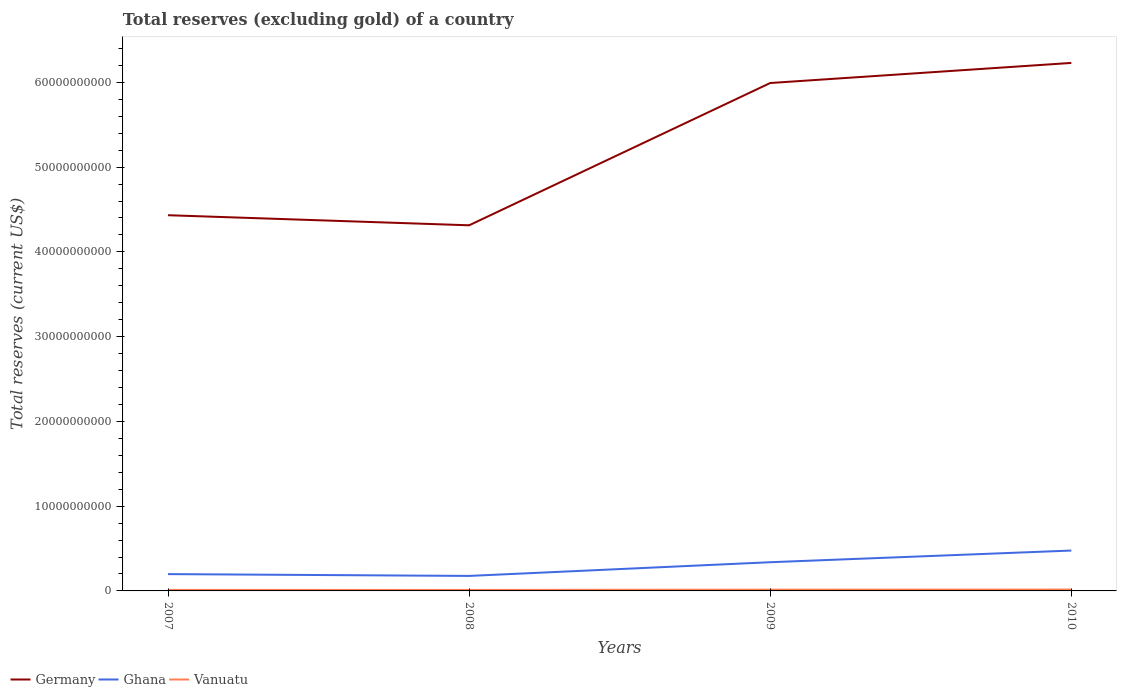Does the line corresponding to Germany intersect with the line corresponding to Ghana?
Your answer should be very brief. No. Across all years, what is the maximum total reserves (excluding gold) in Germany?
Provide a succinct answer. 4.31e+1. What is the total total reserves (excluding gold) in Vanuatu in the graph?
Offer a very short reply. -2.90e+07. What is the difference between the highest and the second highest total reserves (excluding gold) in Vanuatu?
Ensure brevity in your answer.  4.62e+07. Is the total reserves (excluding gold) in Ghana strictly greater than the total reserves (excluding gold) in Germany over the years?
Offer a very short reply. Yes. How many lines are there?
Give a very brief answer. 3. Does the graph contain any zero values?
Your response must be concise. No. How many legend labels are there?
Give a very brief answer. 3. What is the title of the graph?
Your response must be concise. Total reserves (excluding gold) of a country. What is the label or title of the Y-axis?
Your answer should be compact. Total reserves (current US$). What is the Total reserves (current US$) of Germany in 2007?
Keep it short and to the point. 4.43e+1. What is the Total reserves (current US$) in Ghana in 2007?
Offer a very short reply. 1.98e+09. What is the Total reserves (current US$) of Vanuatu in 2007?
Give a very brief answer. 1.20e+08. What is the Total reserves (current US$) in Germany in 2008?
Provide a short and direct response. 4.31e+1. What is the Total reserves (current US$) in Ghana in 2008?
Provide a succinct answer. 1.77e+09. What is the Total reserves (current US$) of Vanuatu in 2008?
Ensure brevity in your answer.  1.15e+08. What is the Total reserves (current US$) in Germany in 2009?
Your answer should be very brief. 5.99e+1. What is the Total reserves (current US$) of Ghana in 2009?
Ensure brevity in your answer.  3.39e+09. What is the Total reserves (current US$) of Vanuatu in 2009?
Your answer should be compact. 1.49e+08. What is the Total reserves (current US$) of Germany in 2010?
Give a very brief answer. 6.23e+1. What is the Total reserves (current US$) in Ghana in 2010?
Make the answer very short. 4.76e+09. What is the Total reserves (current US$) in Vanuatu in 2010?
Provide a succinct answer. 1.61e+08. Across all years, what is the maximum Total reserves (current US$) in Germany?
Provide a short and direct response. 6.23e+1. Across all years, what is the maximum Total reserves (current US$) in Ghana?
Provide a succinct answer. 4.76e+09. Across all years, what is the maximum Total reserves (current US$) of Vanuatu?
Offer a very short reply. 1.61e+08. Across all years, what is the minimum Total reserves (current US$) in Germany?
Provide a short and direct response. 4.31e+1. Across all years, what is the minimum Total reserves (current US$) of Ghana?
Provide a succinct answer. 1.77e+09. Across all years, what is the minimum Total reserves (current US$) in Vanuatu?
Offer a very short reply. 1.15e+08. What is the total Total reserves (current US$) in Germany in the graph?
Provide a succinct answer. 2.10e+11. What is the total Total reserves (current US$) in Ghana in the graph?
Provide a short and direct response. 1.19e+1. What is the total Total reserves (current US$) in Vanuatu in the graph?
Provide a succinct answer. 5.45e+08. What is the difference between the Total reserves (current US$) in Germany in 2007 and that in 2008?
Ensure brevity in your answer.  1.19e+09. What is the difference between the Total reserves (current US$) of Ghana in 2007 and that in 2008?
Give a very brief answer. 2.14e+08. What is the difference between the Total reserves (current US$) of Vanuatu in 2007 and that in 2008?
Offer a terse response. 4.39e+06. What is the difference between the Total reserves (current US$) in Germany in 2007 and that in 2009?
Provide a short and direct response. -1.56e+1. What is the difference between the Total reserves (current US$) of Ghana in 2007 and that in 2009?
Keep it short and to the point. -1.40e+09. What is the difference between the Total reserves (current US$) in Vanuatu in 2007 and that in 2009?
Provide a succinct answer. -2.90e+07. What is the difference between the Total reserves (current US$) of Germany in 2007 and that in 2010?
Offer a very short reply. -1.80e+1. What is the difference between the Total reserves (current US$) in Ghana in 2007 and that in 2010?
Provide a short and direct response. -2.78e+09. What is the difference between the Total reserves (current US$) in Vanuatu in 2007 and that in 2010?
Your answer should be very brief. -4.18e+07. What is the difference between the Total reserves (current US$) in Germany in 2008 and that in 2009?
Your answer should be compact. -1.68e+1. What is the difference between the Total reserves (current US$) in Ghana in 2008 and that in 2009?
Offer a terse response. -1.62e+09. What is the difference between the Total reserves (current US$) in Vanuatu in 2008 and that in 2009?
Keep it short and to the point. -3.34e+07. What is the difference between the Total reserves (current US$) in Germany in 2008 and that in 2010?
Your answer should be very brief. -1.92e+1. What is the difference between the Total reserves (current US$) in Ghana in 2008 and that in 2010?
Make the answer very short. -2.99e+09. What is the difference between the Total reserves (current US$) of Vanuatu in 2008 and that in 2010?
Ensure brevity in your answer.  -4.62e+07. What is the difference between the Total reserves (current US$) of Germany in 2009 and that in 2010?
Offer a very short reply. -2.37e+09. What is the difference between the Total reserves (current US$) in Ghana in 2009 and that in 2010?
Offer a terse response. -1.38e+09. What is the difference between the Total reserves (current US$) in Vanuatu in 2009 and that in 2010?
Your response must be concise. -1.28e+07. What is the difference between the Total reserves (current US$) in Germany in 2007 and the Total reserves (current US$) in Ghana in 2008?
Your response must be concise. 4.26e+1. What is the difference between the Total reserves (current US$) of Germany in 2007 and the Total reserves (current US$) of Vanuatu in 2008?
Give a very brief answer. 4.42e+1. What is the difference between the Total reserves (current US$) of Ghana in 2007 and the Total reserves (current US$) of Vanuatu in 2008?
Your answer should be very brief. 1.87e+09. What is the difference between the Total reserves (current US$) of Germany in 2007 and the Total reserves (current US$) of Ghana in 2009?
Offer a very short reply. 4.09e+1. What is the difference between the Total reserves (current US$) of Germany in 2007 and the Total reserves (current US$) of Vanuatu in 2009?
Provide a short and direct response. 4.42e+1. What is the difference between the Total reserves (current US$) of Ghana in 2007 and the Total reserves (current US$) of Vanuatu in 2009?
Give a very brief answer. 1.84e+09. What is the difference between the Total reserves (current US$) in Germany in 2007 and the Total reserves (current US$) in Ghana in 2010?
Provide a short and direct response. 3.96e+1. What is the difference between the Total reserves (current US$) of Germany in 2007 and the Total reserves (current US$) of Vanuatu in 2010?
Offer a very short reply. 4.42e+1. What is the difference between the Total reserves (current US$) in Ghana in 2007 and the Total reserves (current US$) in Vanuatu in 2010?
Offer a very short reply. 1.82e+09. What is the difference between the Total reserves (current US$) of Germany in 2008 and the Total reserves (current US$) of Ghana in 2009?
Provide a short and direct response. 3.98e+1. What is the difference between the Total reserves (current US$) in Germany in 2008 and the Total reserves (current US$) in Vanuatu in 2009?
Your answer should be very brief. 4.30e+1. What is the difference between the Total reserves (current US$) in Ghana in 2008 and the Total reserves (current US$) in Vanuatu in 2009?
Give a very brief answer. 1.62e+09. What is the difference between the Total reserves (current US$) in Germany in 2008 and the Total reserves (current US$) in Ghana in 2010?
Your response must be concise. 3.84e+1. What is the difference between the Total reserves (current US$) in Germany in 2008 and the Total reserves (current US$) in Vanuatu in 2010?
Your answer should be compact. 4.30e+1. What is the difference between the Total reserves (current US$) of Ghana in 2008 and the Total reserves (current US$) of Vanuatu in 2010?
Provide a succinct answer. 1.61e+09. What is the difference between the Total reserves (current US$) of Germany in 2009 and the Total reserves (current US$) of Ghana in 2010?
Your answer should be compact. 5.52e+1. What is the difference between the Total reserves (current US$) of Germany in 2009 and the Total reserves (current US$) of Vanuatu in 2010?
Offer a terse response. 5.98e+1. What is the difference between the Total reserves (current US$) of Ghana in 2009 and the Total reserves (current US$) of Vanuatu in 2010?
Offer a very short reply. 3.22e+09. What is the average Total reserves (current US$) in Germany per year?
Make the answer very short. 5.24e+1. What is the average Total reserves (current US$) in Ghana per year?
Your answer should be compact. 2.98e+09. What is the average Total reserves (current US$) of Vanuatu per year?
Keep it short and to the point. 1.36e+08. In the year 2007, what is the difference between the Total reserves (current US$) of Germany and Total reserves (current US$) of Ghana?
Ensure brevity in your answer.  4.23e+1. In the year 2007, what is the difference between the Total reserves (current US$) in Germany and Total reserves (current US$) in Vanuatu?
Your response must be concise. 4.42e+1. In the year 2007, what is the difference between the Total reserves (current US$) of Ghana and Total reserves (current US$) of Vanuatu?
Keep it short and to the point. 1.86e+09. In the year 2008, what is the difference between the Total reserves (current US$) in Germany and Total reserves (current US$) in Ghana?
Your answer should be very brief. 4.14e+1. In the year 2008, what is the difference between the Total reserves (current US$) of Germany and Total reserves (current US$) of Vanuatu?
Offer a terse response. 4.30e+1. In the year 2008, what is the difference between the Total reserves (current US$) in Ghana and Total reserves (current US$) in Vanuatu?
Ensure brevity in your answer.  1.65e+09. In the year 2009, what is the difference between the Total reserves (current US$) in Germany and Total reserves (current US$) in Ghana?
Your answer should be very brief. 5.65e+1. In the year 2009, what is the difference between the Total reserves (current US$) of Germany and Total reserves (current US$) of Vanuatu?
Offer a very short reply. 5.98e+1. In the year 2009, what is the difference between the Total reserves (current US$) in Ghana and Total reserves (current US$) in Vanuatu?
Your response must be concise. 3.24e+09. In the year 2010, what is the difference between the Total reserves (current US$) in Germany and Total reserves (current US$) in Ghana?
Provide a short and direct response. 5.75e+1. In the year 2010, what is the difference between the Total reserves (current US$) in Germany and Total reserves (current US$) in Vanuatu?
Offer a very short reply. 6.21e+1. In the year 2010, what is the difference between the Total reserves (current US$) of Ghana and Total reserves (current US$) of Vanuatu?
Provide a short and direct response. 4.60e+09. What is the ratio of the Total reserves (current US$) in Germany in 2007 to that in 2008?
Offer a very short reply. 1.03. What is the ratio of the Total reserves (current US$) of Ghana in 2007 to that in 2008?
Give a very brief answer. 1.12. What is the ratio of the Total reserves (current US$) of Vanuatu in 2007 to that in 2008?
Your response must be concise. 1.04. What is the ratio of the Total reserves (current US$) of Germany in 2007 to that in 2009?
Your answer should be very brief. 0.74. What is the ratio of the Total reserves (current US$) of Ghana in 2007 to that in 2009?
Give a very brief answer. 0.59. What is the ratio of the Total reserves (current US$) of Vanuatu in 2007 to that in 2009?
Keep it short and to the point. 0.8. What is the ratio of the Total reserves (current US$) of Germany in 2007 to that in 2010?
Offer a very short reply. 0.71. What is the ratio of the Total reserves (current US$) of Ghana in 2007 to that in 2010?
Provide a short and direct response. 0.42. What is the ratio of the Total reserves (current US$) in Vanuatu in 2007 to that in 2010?
Give a very brief answer. 0.74. What is the ratio of the Total reserves (current US$) in Germany in 2008 to that in 2009?
Your response must be concise. 0.72. What is the ratio of the Total reserves (current US$) in Ghana in 2008 to that in 2009?
Offer a terse response. 0.52. What is the ratio of the Total reserves (current US$) of Vanuatu in 2008 to that in 2009?
Provide a succinct answer. 0.78. What is the ratio of the Total reserves (current US$) in Germany in 2008 to that in 2010?
Your answer should be very brief. 0.69. What is the ratio of the Total reserves (current US$) of Ghana in 2008 to that in 2010?
Provide a succinct answer. 0.37. What is the ratio of the Total reserves (current US$) in Vanuatu in 2008 to that in 2010?
Offer a very short reply. 0.71. What is the ratio of the Total reserves (current US$) of Ghana in 2009 to that in 2010?
Offer a very short reply. 0.71. What is the ratio of the Total reserves (current US$) in Vanuatu in 2009 to that in 2010?
Provide a succinct answer. 0.92. What is the difference between the highest and the second highest Total reserves (current US$) in Germany?
Your response must be concise. 2.37e+09. What is the difference between the highest and the second highest Total reserves (current US$) of Ghana?
Provide a succinct answer. 1.38e+09. What is the difference between the highest and the second highest Total reserves (current US$) in Vanuatu?
Your answer should be compact. 1.28e+07. What is the difference between the highest and the lowest Total reserves (current US$) in Germany?
Ensure brevity in your answer.  1.92e+1. What is the difference between the highest and the lowest Total reserves (current US$) in Ghana?
Your answer should be compact. 2.99e+09. What is the difference between the highest and the lowest Total reserves (current US$) of Vanuatu?
Ensure brevity in your answer.  4.62e+07. 